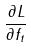<formula> <loc_0><loc_0><loc_500><loc_500>\frac { \partial L } { \partial f _ { t } }</formula> 